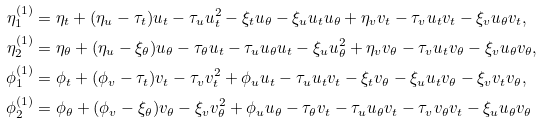Convert formula to latex. <formula><loc_0><loc_0><loc_500><loc_500>\eta ^ { ( 1 ) } _ { 1 } & = \eta _ { t } + ( \eta _ { u } - \tau _ { t } ) u _ { t } - \tau _ { u } u ^ { 2 } _ { t } - \xi _ { t } u _ { \theta } - \xi _ { u } u _ { t } u _ { \theta } + \eta _ { v } v _ { t } - \tau _ { v } u _ { t } v _ { t } - \xi _ { v } u _ { \theta } v _ { t } , \\ \eta ^ { ( 1 ) } _ { 2 } & = \eta _ { \theta } + ( \eta _ { u } - \xi _ { \theta } ) u _ { \theta } - \tau _ { \theta } u _ { t } - \tau _ { u } u _ { \theta } u _ { t } - \xi _ { u } u ^ { 2 } _ { \theta } + \eta _ { v } v _ { \theta } - \tau _ { v } u _ { t } v _ { \theta } - \xi _ { v } u _ { \theta } v _ { \theta } , \\ \phi ^ { ( 1 ) } _ { 1 } & = \phi _ { t } + ( \phi _ { v } - \tau _ { t } ) v _ { t } - \tau _ { v } v ^ { 2 } _ { t } + \phi _ { u } u _ { t } - \tau _ { u } u _ { t } v _ { t } - \xi _ { t } v _ { \theta } - \xi _ { u } u _ { t } v _ { \theta } - \xi _ { v } v _ { t } v _ { \theta } , \\ \phi ^ { ( 1 ) } _ { 2 } & = \phi _ { \theta } + ( \phi _ { v } - \xi _ { \theta } ) v _ { \theta } - \xi _ { v } v ^ { 2 } _ { \theta } + \phi _ { u } u _ { \theta } - \tau _ { \theta } v _ { t } - \tau _ { u } u _ { \theta } v _ { t } - \tau _ { v } v _ { \theta } v _ { t } - \xi _ { u } u _ { \theta } v _ { \theta }</formula> 